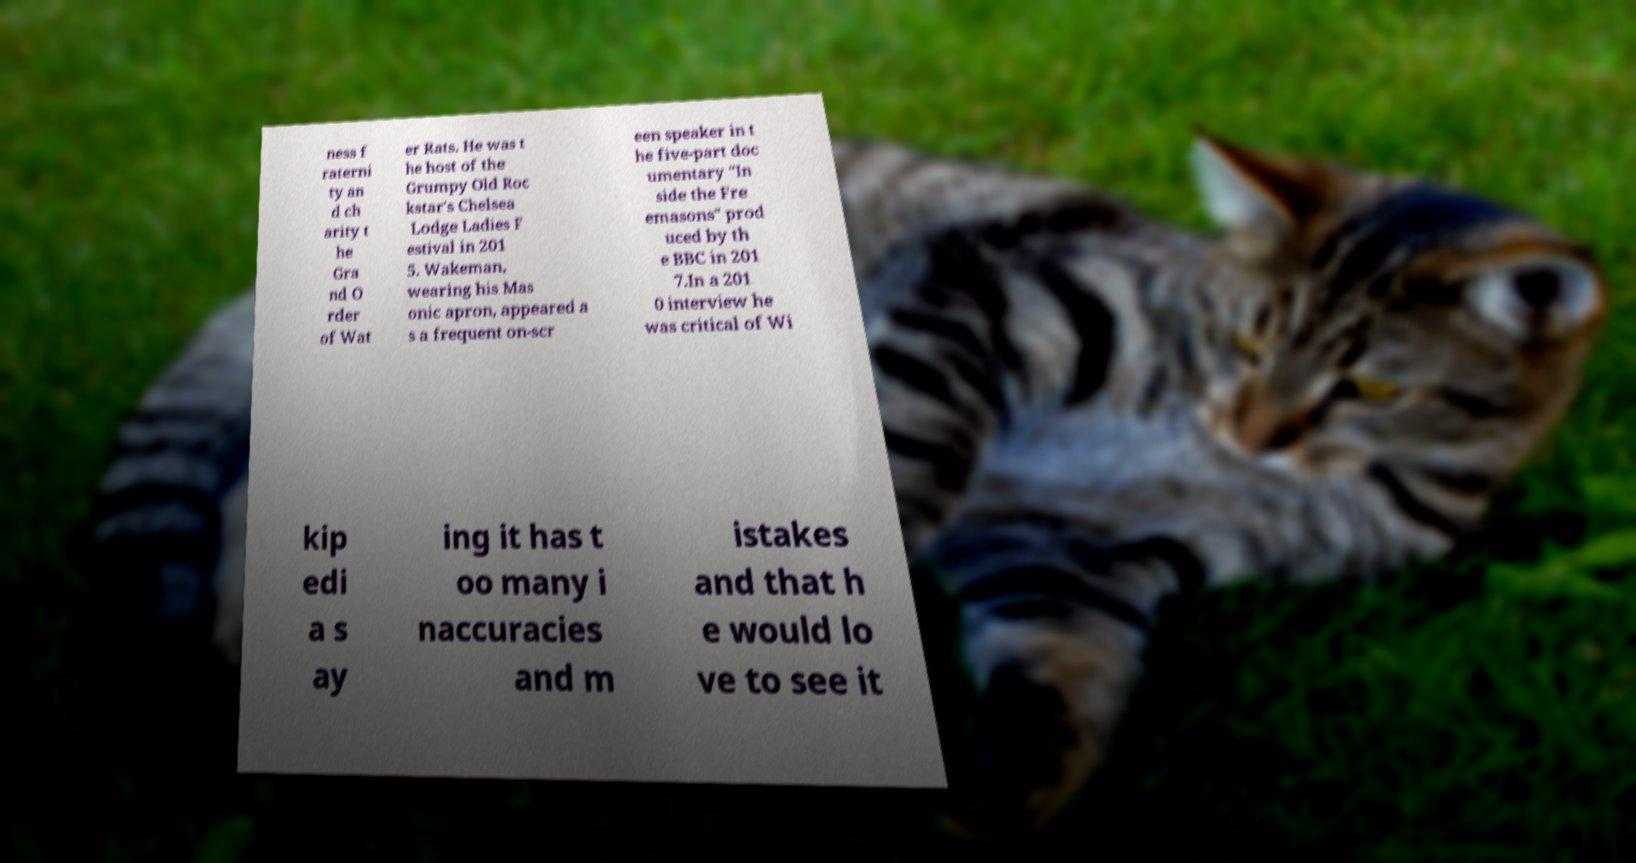What messages or text are displayed in this image? I need them in a readable, typed format. ness f raterni ty an d ch arity t he Gra nd O rder of Wat er Rats. He was t he host of the Grumpy Old Roc kstar's Chelsea Lodge Ladies F estival in 201 5. Wakeman, wearing his Mas onic apron, appeared a s a frequent on-scr een speaker in t he five-part doc umentary "In side the Fre emasons" prod uced by th e BBC in 201 7.In a 201 0 interview he was critical of Wi kip edi a s ay ing it has t oo many i naccuracies and m istakes and that h e would lo ve to see it 